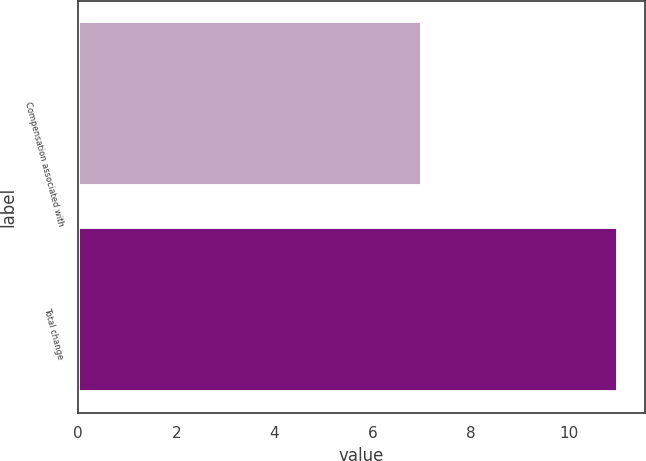Convert chart. <chart><loc_0><loc_0><loc_500><loc_500><bar_chart><fcel>Compensation associated with<fcel>Total change<nl><fcel>7<fcel>11<nl></chart> 